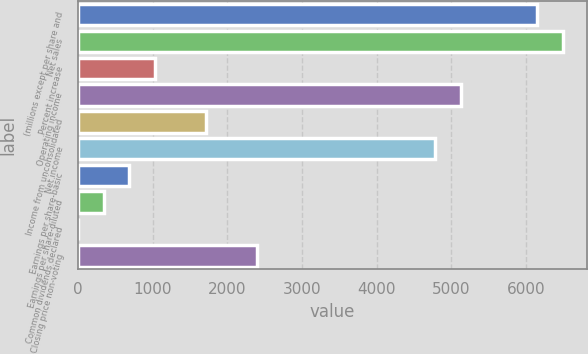<chart> <loc_0><loc_0><loc_500><loc_500><bar_chart><fcel>(millions except per share and<fcel>Net sales<fcel>Percent increase<fcel>Operating income<fcel>Income from unconsolidated<fcel>Net income<fcel>Earnings per share-basic<fcel>Earnings per share-diluted<fcel>Common dividends declared<fcel>Closing price non-voting<nl><fcel>6154.54<fcel>6496.4<fcel>1026.64<fcel>5128.96<fcel>1710.36<fcel>4787.1<fcel>684.78<fcel>342.92<fcel>1.06<fcel>2394.08<nl></chart> 